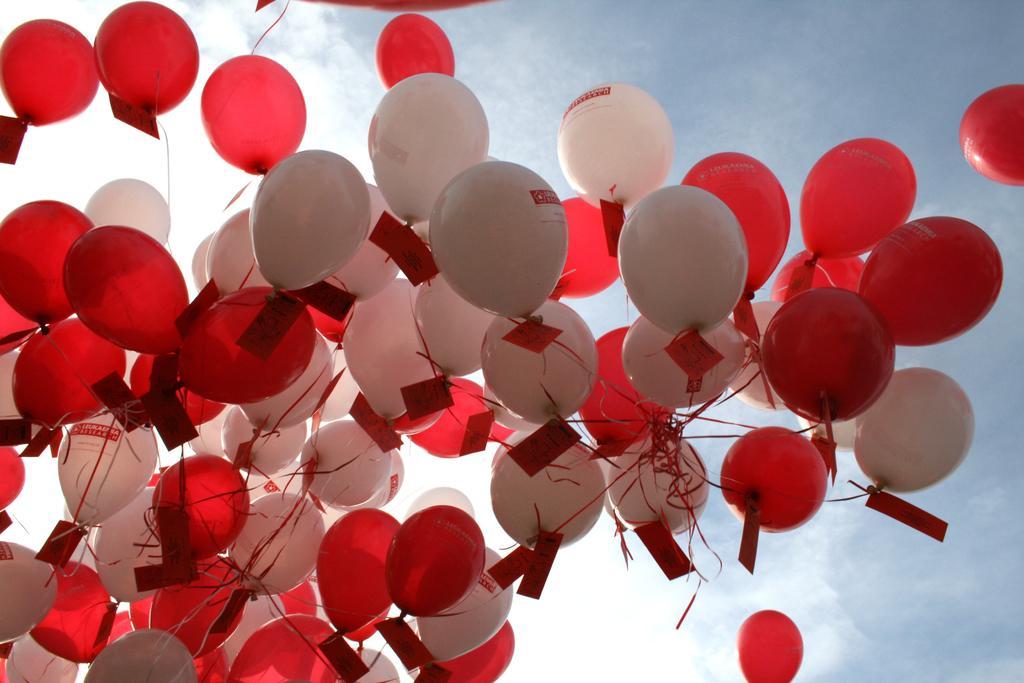Can you describe this image briefly? In front of the image there are balloons. In the background of the image there is sky. 